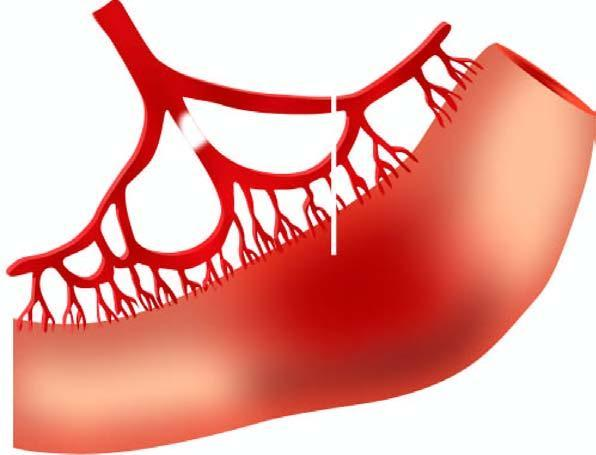s the affected part soft, swollen and dark?
Answer the question using a single word or phrase. Yes 